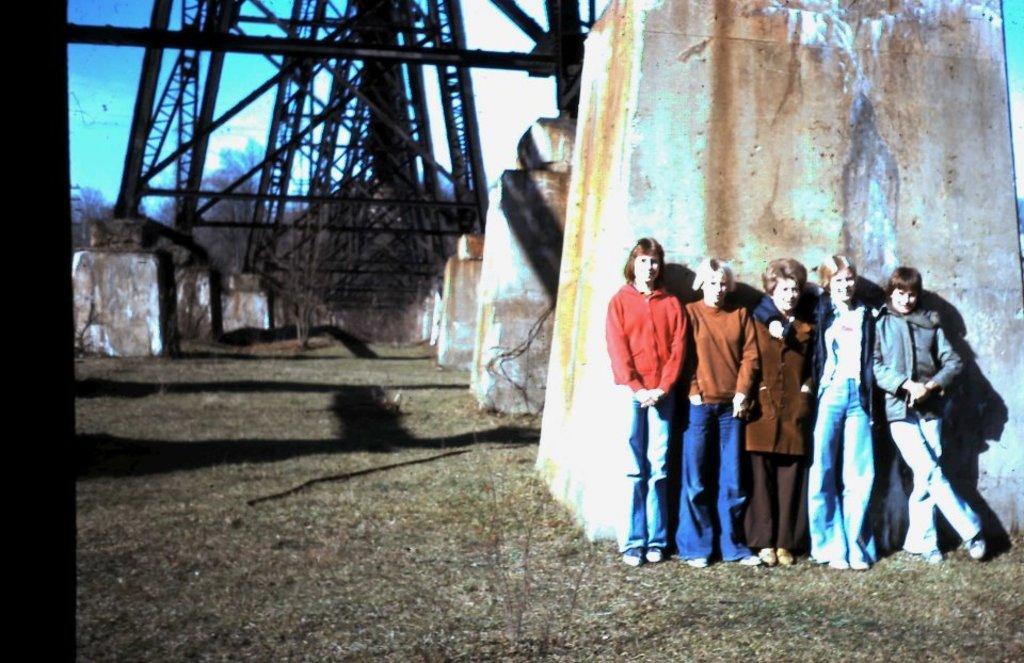Describe this image in one or two sentences. In this image we can see a group of women standing on the ground. In the background, we can see some metal frames placed on concrete surfaces, group of trees and the sky, 